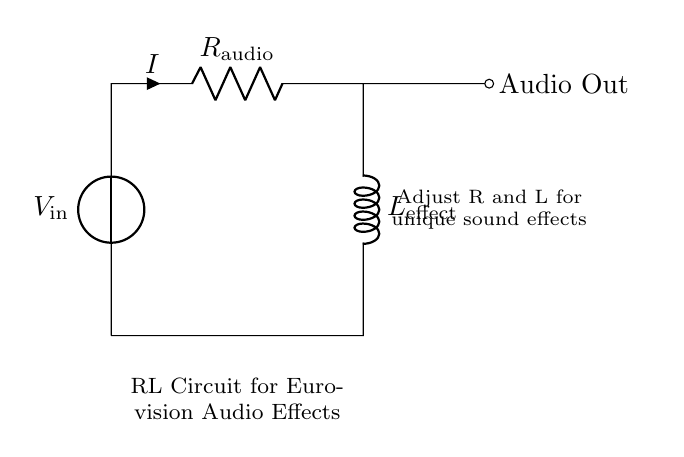What is the type of this circuit? The circuit consists of a resistor and an inductor, making it an RL circuit.
Answer: RL circuit What is the role of the resistor in this circuit? The resistor limits the current flowing through the circuit, which influences the audio output and affects the sound dynamics.
Answer: Current limiter What does the variable L represent in this circuit? The variable L stands for the inductance of the inductor used for creating audio effects, which can be adjusted for different sound characteristics.
Answer: Inductance What is the purpose of the voltage source in this circuit? The voltage source provides the necessary electrical energy to drive the circuit, allowing the audio effects to be generated.
Answer: Power supply How can adjusting R and L affect the audio output? Changing the values of R and L alters the circuitry’s response to current, which modifies the frequency characteristics of the audio output, creating different effects.
Answer: Alters sound dynamics What happens to the current if R is increased? Increasing R will reduce the current flowing through the circuit, as per Ohm's Law, leading to softer audio effects.
Answer: Decrease in current What is the output labeled as in this circuit? The output is labeled as "Audio Out," indicating where the processed audio signal can be taken from the circuit for amplification or effects.
Answer: Audio Out 